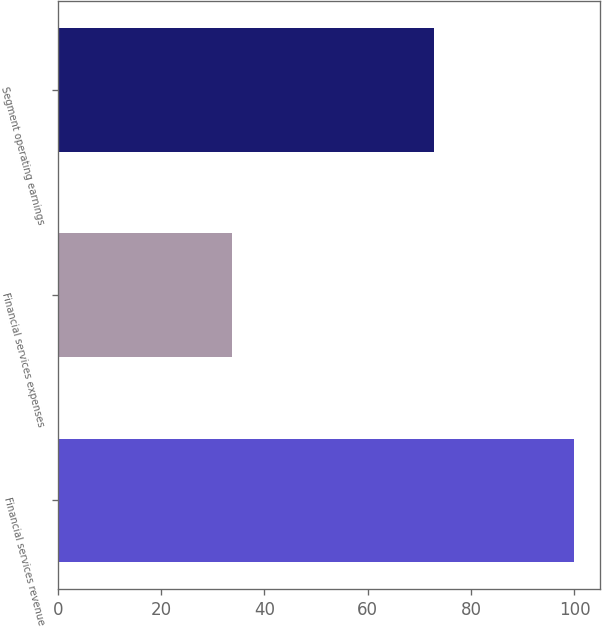<chart> <loc_0><loc_0><loc_500><loc_500><bar_chart><fcel>Financial services revenue<fcel>Financial services expenses<fcel>Segment operating earnings<nl><fcel>100<fcel>33.8<fcel>72.82<nl></chart> 